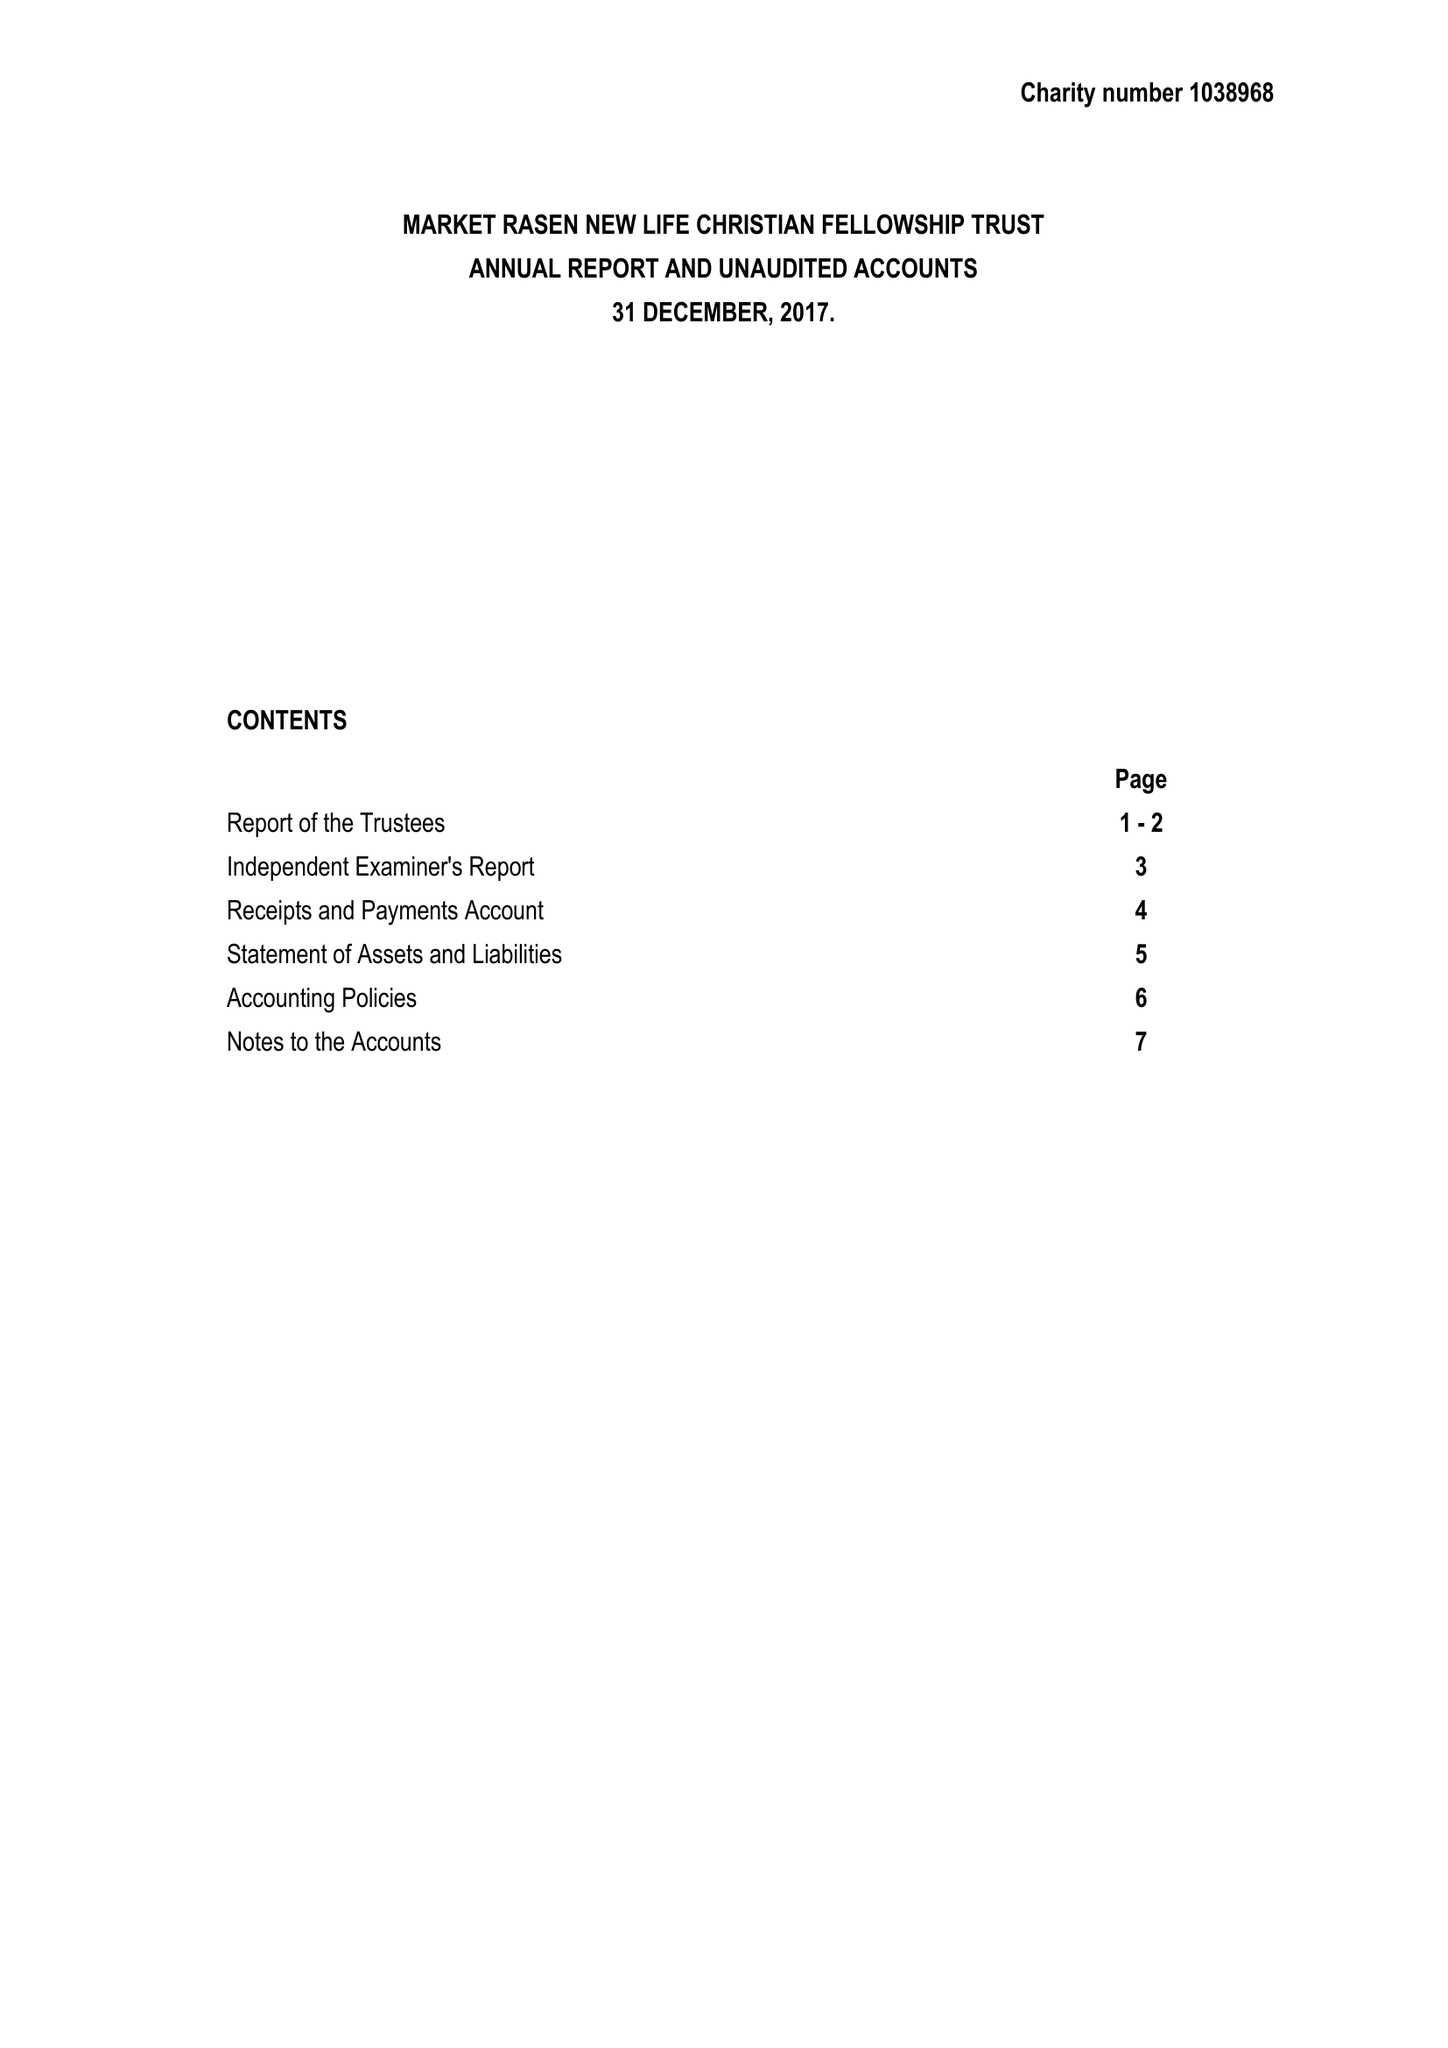What is the value for the charity_number?
Answer the question using a single word or phrase. 1038968 